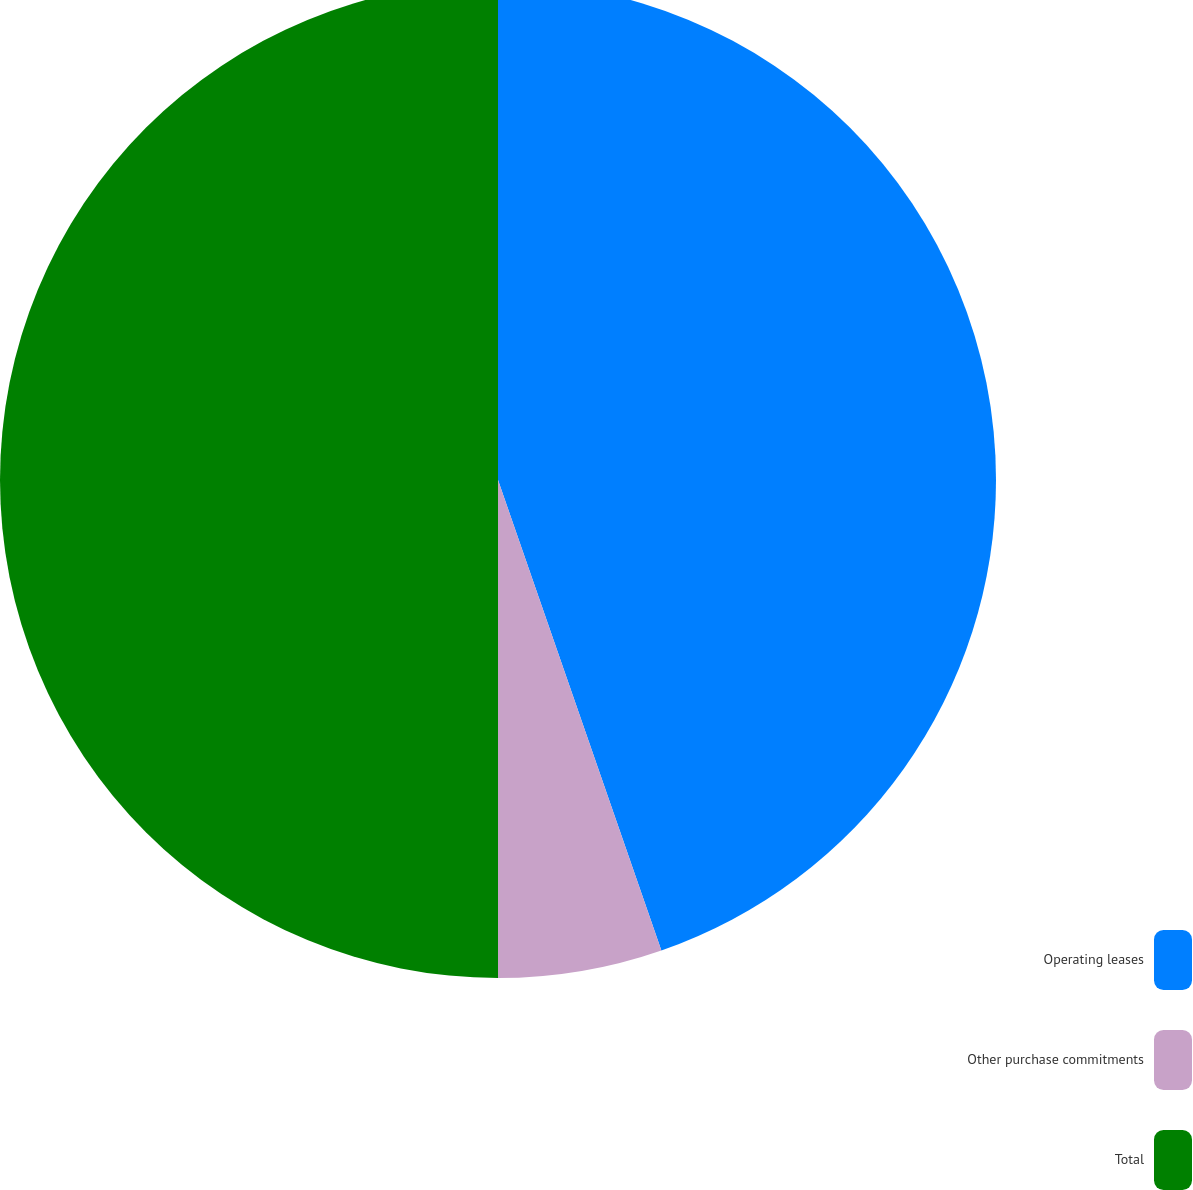Convert chart. <chart><loc_0><loc_0><loc_500><loc_500><pie_chart><fcel>Operating leases<fcel>Other purchase commitments<fcel>Total<nl><fcel>44.68%<fcel>5.32%<fcel>50.0%<nl></chart> 